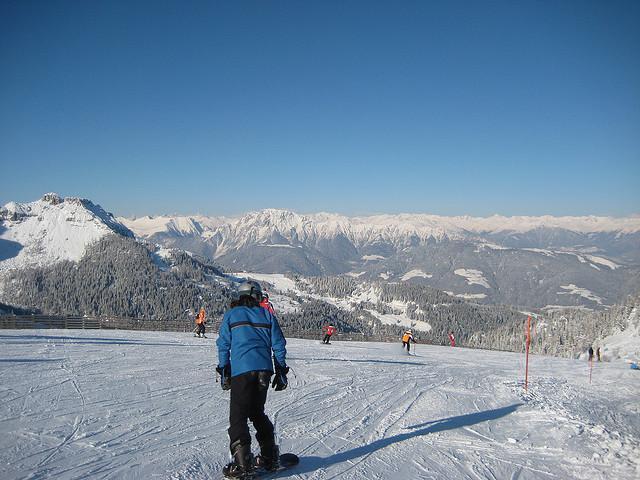How many suitcases are on the carousel?
Give a very brief answer. 0. 